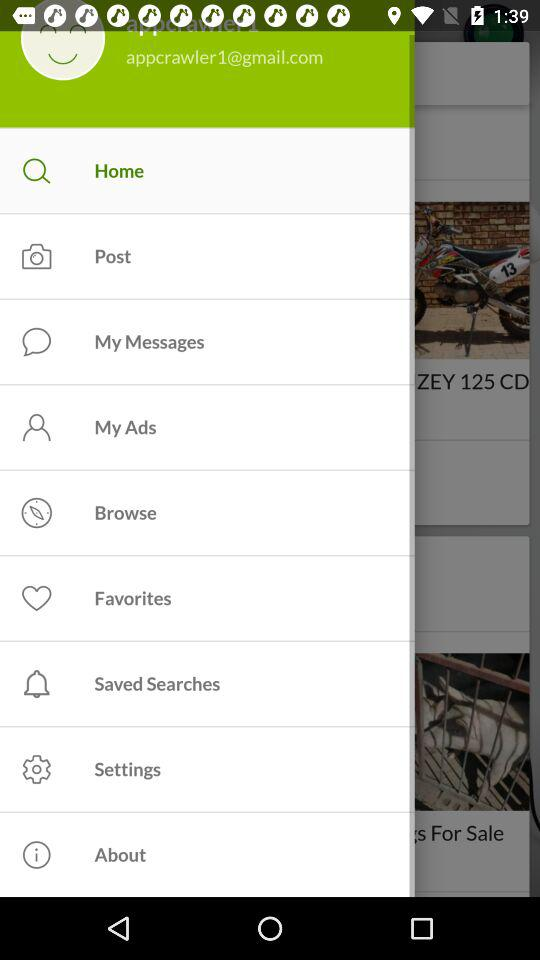How many notifications are there in "Settings"?
When the provided information is insufficient, respond with <no answer>. <no answer> 